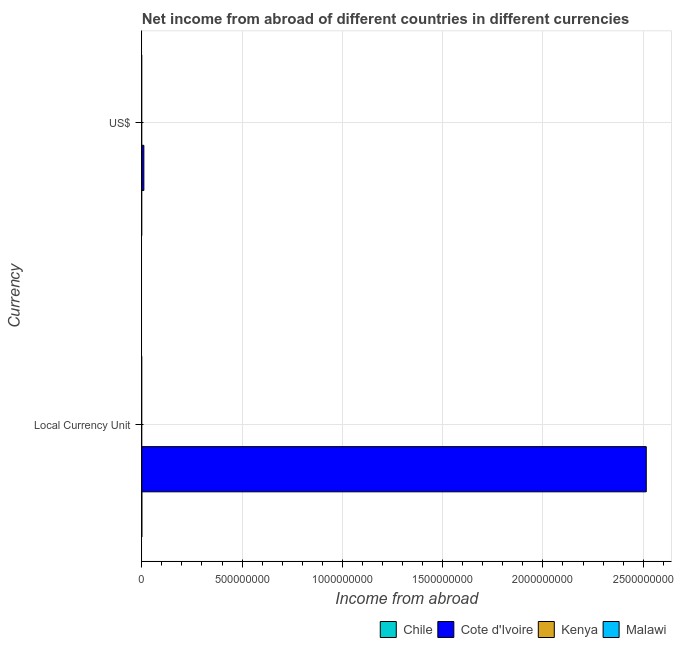Are the number of bars per tick equal to the number of legend labels?
Your response must be concise. No. How many bars are there on the 1st tick from the top?
Keep it short and to the point. 1. How many bars are there on the 2nd tick from the bottom?
Provide a succinct answer. 1. What is the label of the 2nd group of bars from the top?
Make the answer very short. Local Currency Unit. Across all countries, what is the maximum income from abroad in constant 2005 us$?
Provide a short and direct response. 2.52e+09. Across all countries, what is the minimum income from abroad in us$?
Make the answer very short. 0. In which country was the income from abroad in us$ maximum?
Your answer should be compact. Cote d'Ivoire. What is the total income from abroad in constant 2005 us$ in the graph?
Your answer should be compact. 2.52e+09. What is the difference between the income from abroad in us$ in Cote d'Ivoire and the income from abroad in constant 2005 us$ in Malawi?
Make the answer very short. 1.03e+07. What is the average income from abroad in constant 2005 us$ per country?
Make the answer very short. 6.29e+08. What is the difference between the income from abroad in constant 2005 us$ and income from abroad in us$ in Cote d'Ivoire?
Keep it short and to the point. 2.51e+09. How many countries are there in the graph?
Offer a terse response. 4. Does the graph contain any zero values?
Your answer should be compact. Yes. Does the graph contain grids?
Offer a terse response. Yes. Where does the legend appear in the graph?
Ensure brevity in your answer.  Bottom right. What is the title of the graph?
Offer a terse response. Net income from abroad of different countries in different currencies. Does "Malaysia" appear as one of the legend labels in the graph?
Your answer should be compact. No. What is the label or title of the X-axis?
Make the answer very short. Income from abroad. What is the label or title of the Y-axis?
Keep it short and to the point. Currency. What is the Income from abroad of Chile in Local Currency Unit?
Give a very brief answer. 0. What is the Income from abroad of Cote d'Ivoire in Local Currency Unit?
Your response must be concise. 2.52e+09. What is the Income from abroad of Kenya in Local Currency Unit?
Keep it short and to the point. 0. What is the Income from abroad in Malawi in Local Currency Unit?
Your answer should be compact. 0. What is the Income from abroad of Cote d'Ivoire in US$?
Provide a succinct answer. 1.03e+07. What is the Income from abroad in Kenya in US$?
Provide a short and direct response. 0. What is the Income from abroad in Malawi in US$?
Your answer should be very brief. 0. Across all Currency, what is the maximum Income from abroad in Cote d'Ivoire?
Give a very brief answer. 2.52e+09. Across all Currency, what is the minimum Income from abroad in Cote d'Ivoire?
Provide a short and direct response. 1.03e+07. What is the total Income from abroad in Chile in the graph?
Ensure brevity in your answer.  0. What is the total Income from abroad of Cote d'Ivoire in the graph?
Offer a very short reply. 2.53e+09. What is the total Income from abroad in Malawi in the graph?
Provide a succinct answer. 0. What is the difference between the Income from abroad of Cote d'Ivoire in Local Currency Unit and that in US$?
Ensure brevity in your answer.  2.51e+09. What is the average Income from abroad of Cote d'Ivoire per Currency?
Ensure brevity in your answer.  1.26e+09. What is the average Income from abroad in Kenya per Currency?
Keep it short and to the point. 0. What is the average Income from abroad in Malawi per Currency?
Provide a short and direct response. 0. What is the ratio of the Income from abroad in Cote d'Ivoire in Local Currency Unit to that in US$?
Provide a succinct answer. 245.2. What is the difference between the highest and the second highest Income from abroad in Cote d'Ivoire?
Give a very brief answer. 2.51e+09. What is the difference between the highest and the lowest Income from abroad of Cote d'Ivoire?
Your answer should be very brief. 2.51e+09. 